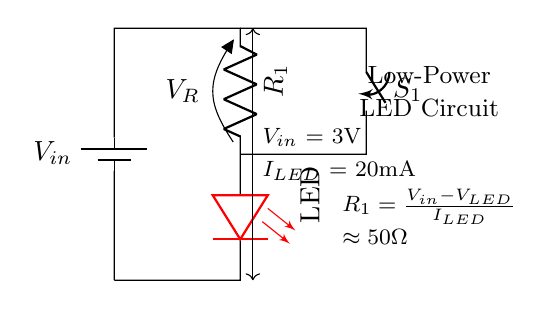What is the input voltage for this circuit? The input voltage is labeled as V_in, shown to be equal to 3V.
Answer: 3 volts What type of LED is used in this circuit? The circuit diagram indicates a red LED, specified under the LED component.
Answer: Red What is the purpose of the switch in the circuit? The switch (S_1) is used to control the flow of current in the circuit, allowing for turning the LED on or off.
Answer: Control What is the calculated resistance value for R_1? The resistance R_1 is calculated using the formula provided, which yields approximately 50 ohms.
Answer: Approximately 50 ohms How much current flows through the LED? The current flowing through the LED is given as I_LED, which is stated to be 20 mA in the circuit.
Answer: 20 mA What happens to the LED when the switch is closed? When S_1 is closed, the circuit completes, allowing current to flow and the LED to light up.
Answer: Lights up What is the purpose of the resistor R_1 in the circuit? Resistor R_1 is used to limit the current flowing through the LED, preventing damage from excessive current.
Answer: Current limiter 